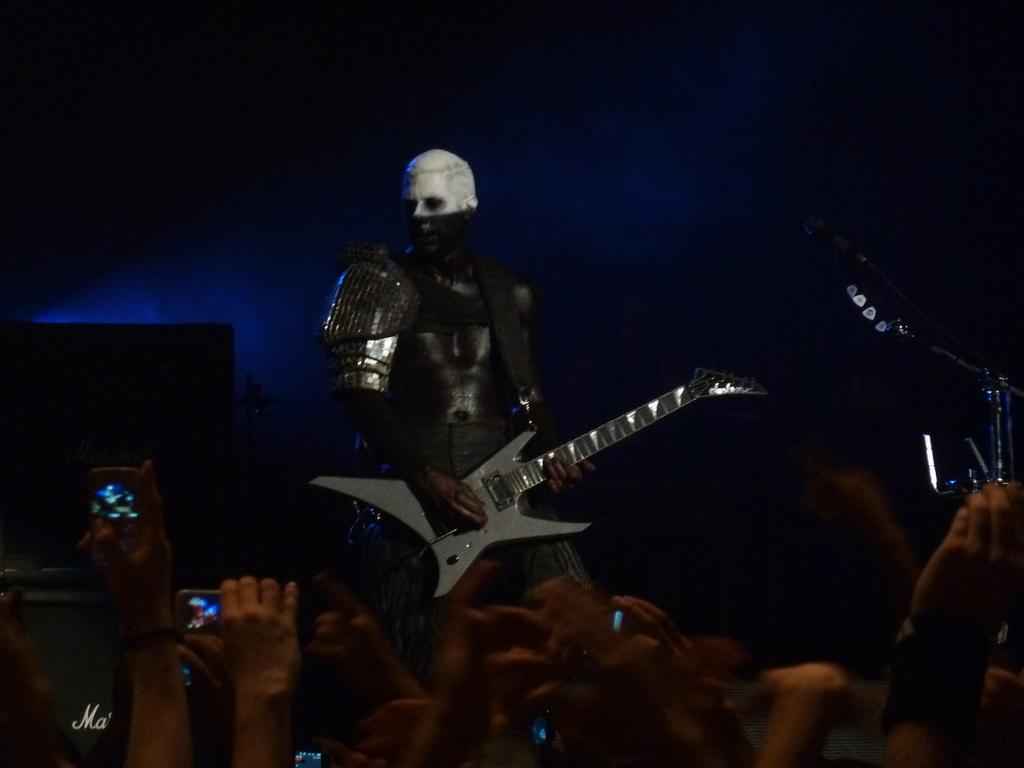Who is the main subject in the image? There is a person in the image. Where is the person located in the image? The person is standing in the middle of the image. What is the person wearing? The person is wearing a silver suit. What is the person doing in the image? The person is playing a guitar. What can be seen in front of the person? There is a crowd in front of the person. What object is present in the corner of the image? There is a microphone in the corner of the image. What type of bag is the person using to wash the title in the image? There is no bag, washing, or title present in the image. 